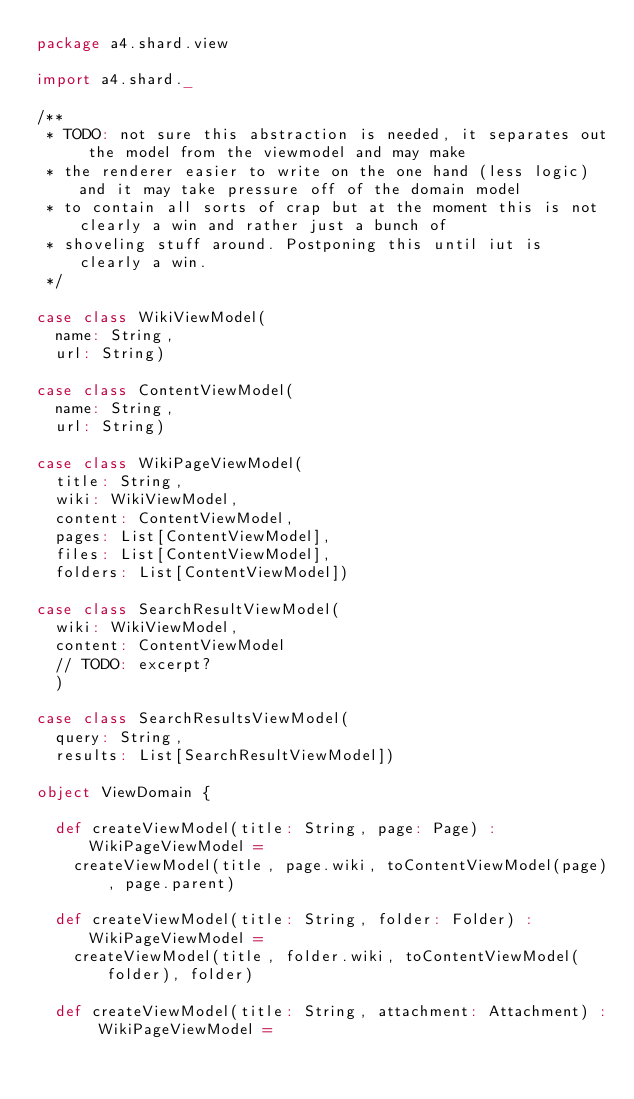<code> <loc_0><loc_0><loc_500><loc_500><_Scala_>package a4.shard.view

import a4.shard._

/**
 * TODO: not sure this abstraction is needed, it separates out the model from the viewmodel and may make
 * the renderer easier to write on the one hand (less logic) and it may take pressure off of the domain model
 * to contain all sorts of crap but at the moment this is not clearly a win and rather just a bunch of
 * shoveling stuff around. Postponing this until iut is clearly a win.
 */

case class WikiViewModel(
  name: String,
  url: String)

case class ContentViewModel(
  name: String,
  url: String)

case class WikiPageViewModel(
  title: String,
  wiki: WikiViewModel,
  content: ContentViewModel,
  pages: List[ContentViewModel],
  files: List[ContentViewModel],
  folders: List[ContentViewModel])

case class SearchResultViewModel(
  wiki: WikiViewModel,
  content: ContentViewModel
  // TODO: excerpt?
  )

case class SearchResultsViewModel(
  query: String,
  results: List[SearchResultViewModel])

object ViewDomain {

  def createViewModel(title: String, page: Page) : WikiPageViewModel =
    createViewModel(title, page.wiki, toContentViewModel(page), page.parent)

  def createViewModel(title: String, folder: Folder) : WikiPageViewModel =
    createViewModel(title, folder.wiki, toContentViewModel(folder), folder)

  def createViewModel(title: String, attachment: Attachment) : WikiPageViewModel =</code> 